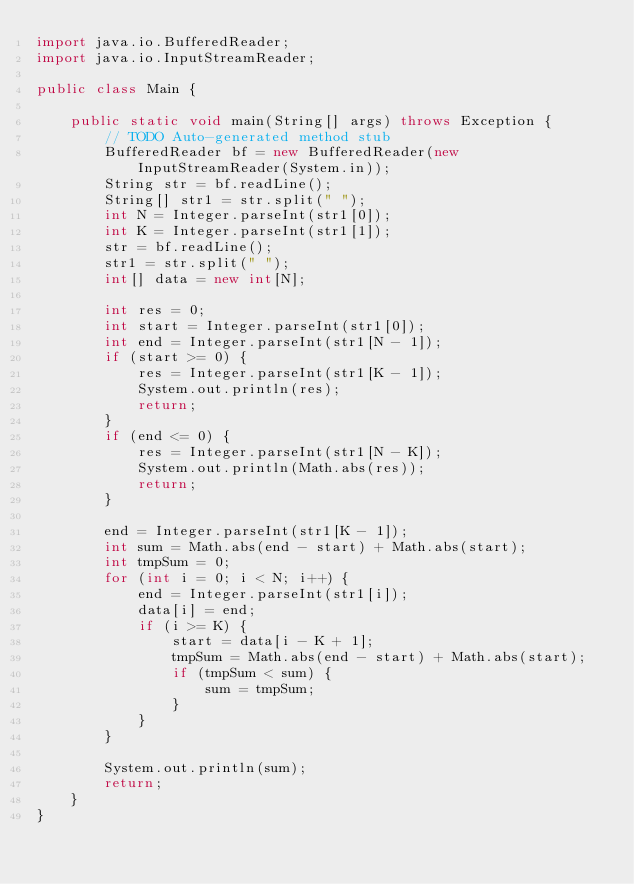<code> <loc_0><loc_0><loc_500><loc_500><_Java_>import java.io.BufferedReader;
import java.io.InputStreamReader;

public class Main {

	public static void main(String[] args) throws Exception {
		// TODO Auto-generated method stub
		BufferedReader bf = new BufferedReader(new InputStreamReader(System.in));
		String str = bf.readLine();
		String[] str1 = str.split(" ");
		int N = Integer.parseInt(str1[0]);
		int K = Integer.parseInt(str1[1]);
		str = bf.readLine();
		str1 = str.split(" ");
		int[] data = new int[N];

		int res = 0;
		int start = Integer.parseInt(str1[0]);
		int end = Integer.parseInt(str1[N - 1]);
		if (start >= 0) {
			res = Integer.parseInt(str1[K - 1]);
			System.out.println(res);
			return;
		}
		if (end <= 0) {
			res = Integer.parseInt(str1[N - K]);
			System.out.println(Math.abs(res));
			return;
		}

		end = Integer.parseInt(str1[K - 1]);
		int sum = Math.abs(end - start) + Math.abs(start);
		int tmpSum = 0;
		for (int i = 0; i < N; i++) {
			end = Integer.parseInt(str1[i]);
			data[i] = end;
			if (i >= K) {
				start = data[i - K + 1];
				tmpSum = Math.abs(end - start) + Math.abs(start);
				if (tmpSum < sum) {
					sum = tmpSum;
				}
			}
		}

		System.out.println(sum);
		return;
	}
}</code> 